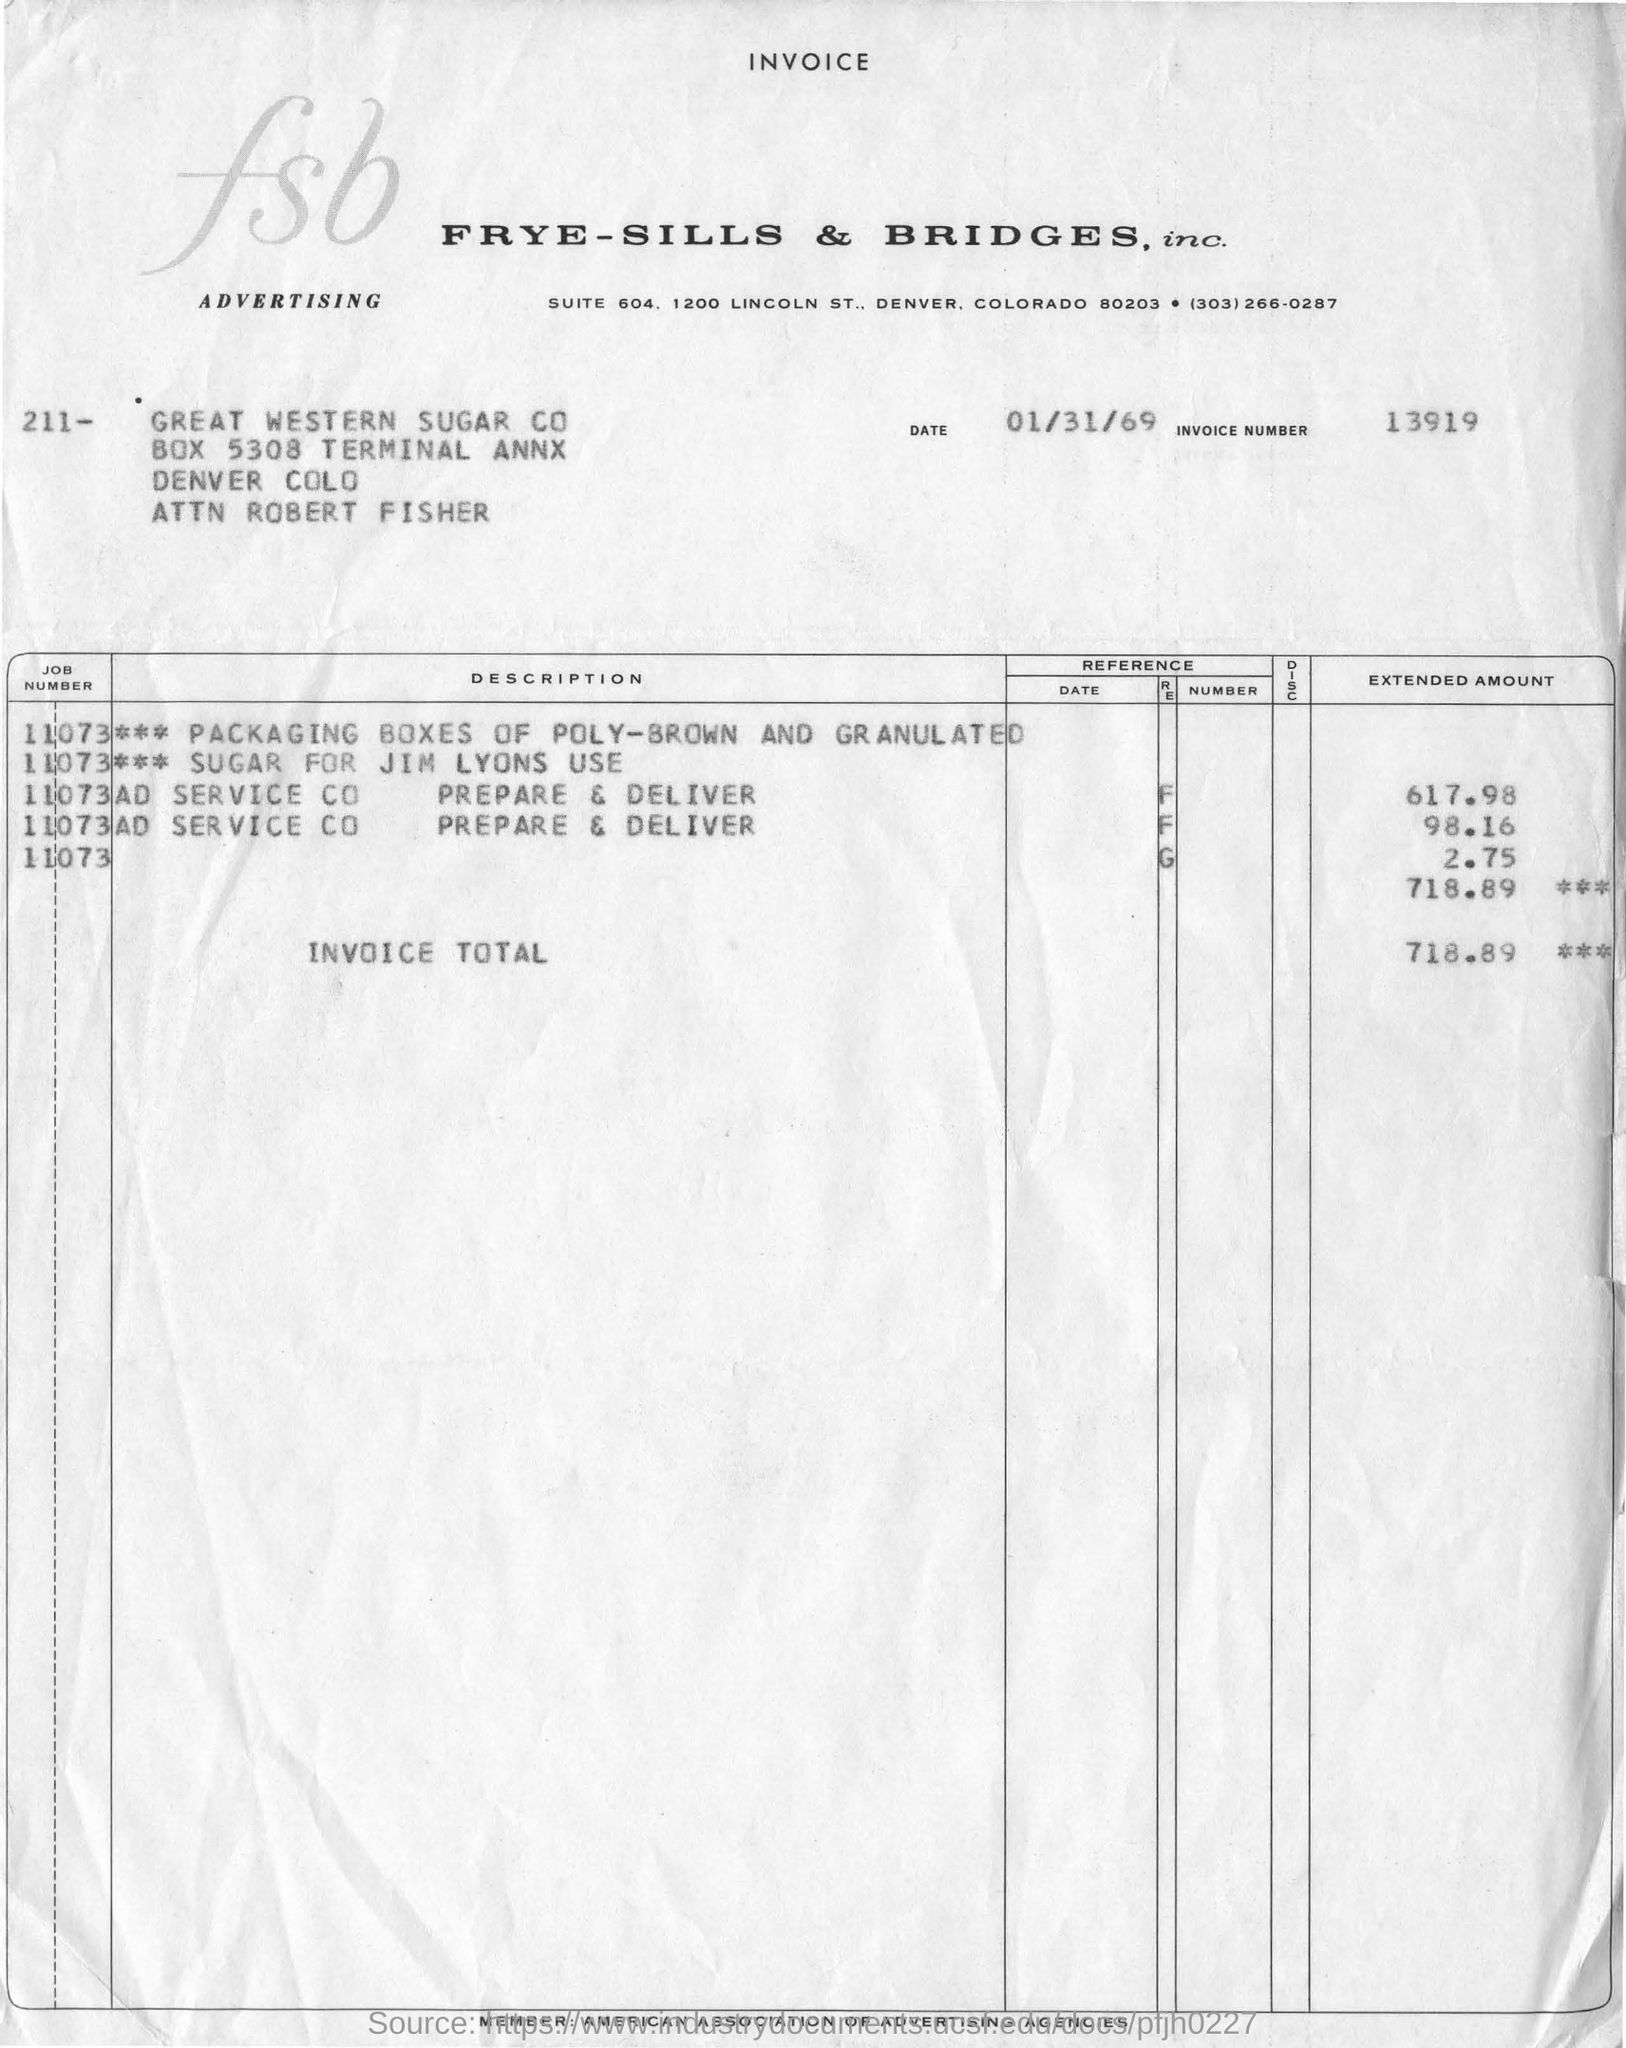Mention a couple of crucial points in this snapshot. The invoice date is January 31, 1969. The invoice number is 13919. The total amount of the invoice is 718.89. The invoice is raised for Frye-Sills & Bridges, Inc. 